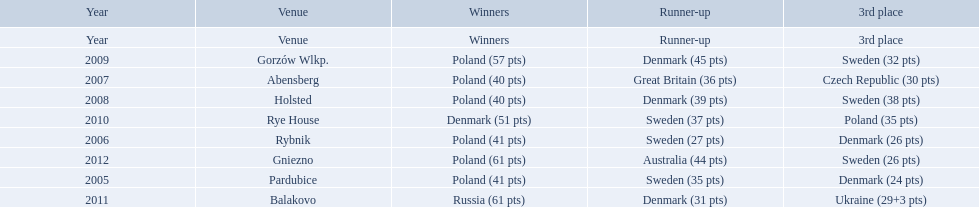After enjoying five consecutive victories at the team speedway junior world championship poland was finally unseated in what year? 2010. In that year, what teams placed first through third? Denmark (51 pts), Sweden (37 pts), Poland (35 pts). Which of those positions did poland specifically place in? 3rd place. 